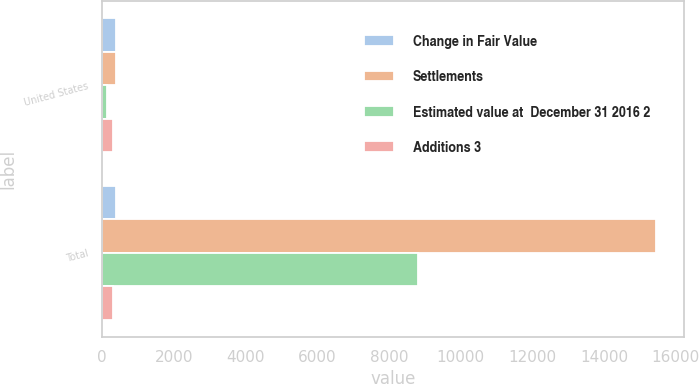Convert chart. <chart><loc_0><loc_0><loc_500><loc_500><stacked_bar_chart><ecel><fcel>United States<fcel>Total<nl><fcel>Change in Fair Value<fcel>393<fcel>393<nl><fcel>Settlements<fcel>393<fcel>15444<nl><fcel>Estimated value at  December 31 2016 2<fcel>119<fcel>8811<nl><fcel>Additions 3<fcel>306<fcel>306<nl></chart> 